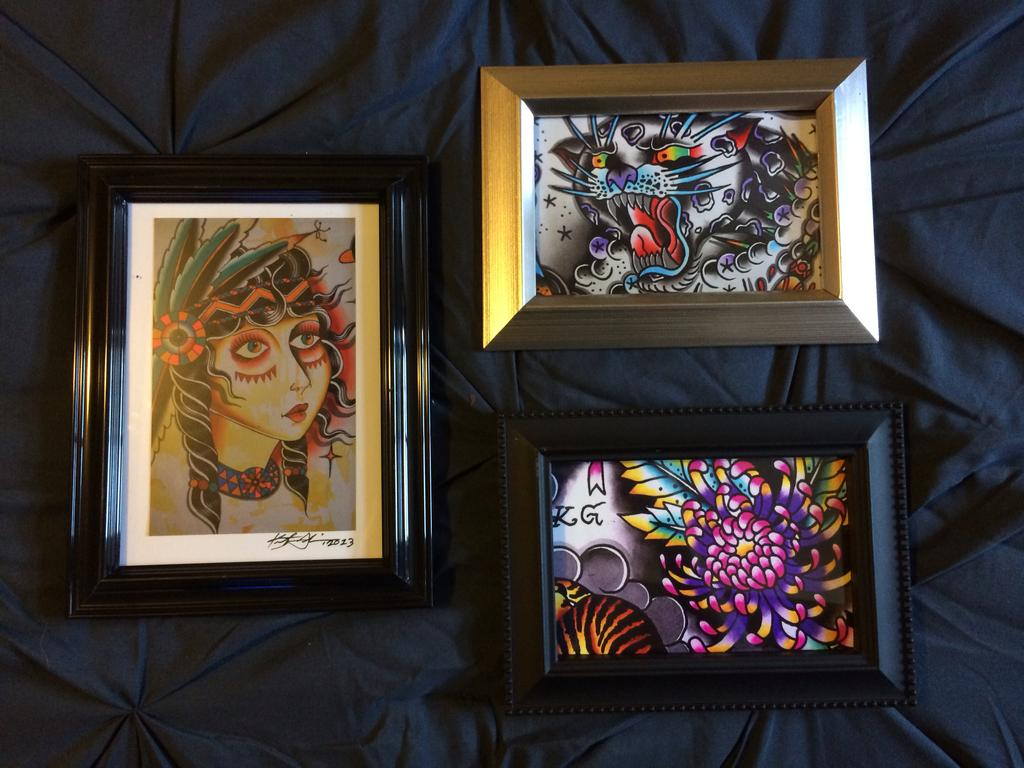How many photo frames are visible in the image? There are three photo frames in the image. What is the photo frames placed on? The photo frames are on a cloth. What type of locket is hanging from the bird in the image? There is no locket or bird present in the image; it only features three photo frames on a cloth. 